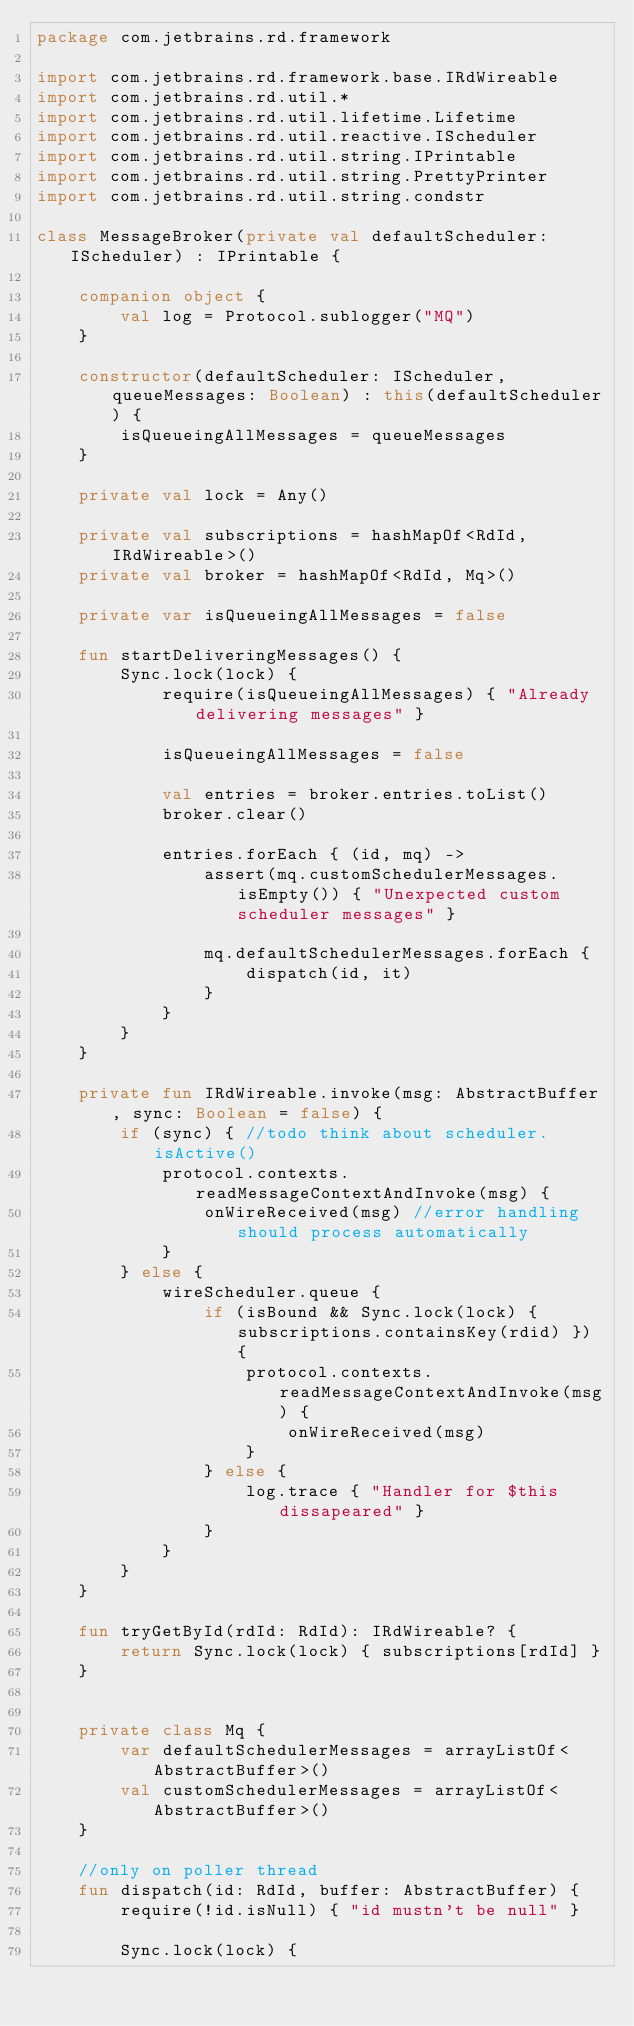<code> <loc_0><loc_0><loc_500><loc_500><_Kotlin_>package com.jetbrains.rd.framework

import com.jetbrains.rd.framework.base.IRdWireable
import com.jetbrains.rd.util.*
import com.jetbrains.rd.util.lifetime.Lifetime
import com.jetbrains.rd.util.reactive.IScheduler
import com.jetbrains.rd.util.string.IPrintable
import com.jetbrains.rd.util.string.PrettyPrinter
import com.jetbrains.rd.util.string.condstr

class MessageBroker(private val defaultScheduler: IScheduler) : IPrintable {

    companion object {
        val log = Protocol.sublogger("MQ")
    }

    constructor(defaultScheduler: IScheduler, queueMessages: Boolean) : this(defaultScheduler) {
        isQueueingAllMessages = queueMessages
    }

    private val lock = Any()

    private val subscriptions = hashMapOf<RdId, IRdWireable>()
    private val broker = hashMapOf<RdId, Mq>()

    private var isQueueingAllMessages = false

    fun startDeliveringMessages() {
        Sync.lock(lock) {
            require(isQueueingAllMessages) { "Already delivering messages" }

            isQueueingAllMessages = false

            val entries = broker.entries.toList()
            broker.clear()

            entries.forEach { (id, mq) ->
                assert(mq.customSchedulerMessages.isEmpty()) { "Unexpected custom scheduler messages" }

                mq.defaultSchedulerMessages.forEach {
                    dispatch(id, it)
                }
            }
        }
    }

    private fun IRdWireable.invoke(msg: AbstractBuffer, sync: Boolean = false) {
        if (sync) { //todo think about scheduler.isActive()
            protocol.contexts.readMessageContextAndInvoke(msg) {
                onWireReceived(msg) //error handling should process automatically
            }
        } else {
            wireScheduler.queue {
                if (isBound && Sync.lock(lock) { subscriptions.containsKey(rdid) }) {
                    protocol.contexts.readMessageContextAndInvoke(msg) {
                        onWireReceived(msg)
                    }
                } else {
                    log.trace { "Handler for $this dissapeared" }
                }
            }
        }
    }

    fun tryGetById(rdId: RdId): IRdWireable? {
        return Sync.lock(lock) { subscriptions[rdId] }
    }


    private class Mq {
        var defaultSchedulerMessages = arrayListOf<AbstractBuffer>()
        val customSchedulerMessages = arrayListOf<AbstractBuffer>()
    }

    //only on poller thread
    fun dispatch(id: RdId, buffer: AbstractBuffer) {
        require(!id.isNull) { "id mustn't be null" }

        Sync.lock(lock) {
</code> 